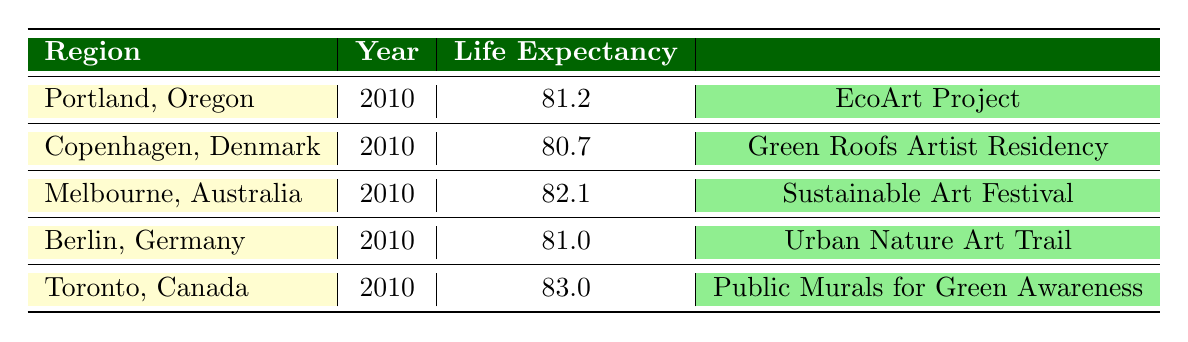What is the average life expectancy listed for Portland, Oregon? The life expectancy for Portland, Oregon, is directly listed in the table as 81.2 years.
Answer: 81.2 Which city has the highest average life expectancy? By comparing the life expectancies across all regions listed, Toronto, Canada, has the highest life expectancy of 83.0 years.
Answer: Toronto, Canada What is the impact rating of the EcoArt Project in Portland? The impact rating for the EcoArt Project is explicitly stated in the table, which is 7.
Answer: 7 Is the life expectancy in Copenhagen, Denmark, higher than that in Berlin, Germany? The table shows that Copenhagen has an average life expectancy of 80.7 years while Berlin has 81.0 years, indicating that Berlin’s life expectancy is higher.
Answer: No What are the average life expectancies for regions with art initiatives rated 8 or higher? The table lists the average life expectancies for Melbourne with an impact rating of 8 (82.1) and Toronto with an impact rating of 8 (83.0). Both need to be averaged: (82.1 + 83.0)/2 = 82.55.
Answer: 82.55 How many regions have an average life expectancy below 82 years? By examining the provided life expectancies: Portland (81.2), Copenhagen (80.7), and Berlin (81.0) are under 82 years, totaling three regions.
Answer: 3 What is the description of the art initiative taking place in Melbourne, Australia? The table states that the initiative, 'Sustainable Art Festival,' emphasizes artists showcasing works that highlight environmental concerns.
Answer: Annual festival where artists showcase works that emphasize environmental concerns Is there a relationship between the impact rating of art initiatives and life expectancy in these regions? A comprehensive review shows Toronto with an initiative rating of 8 and the highest life expectancy of 83.0 years, while Copenhagen, with a lower initiative rating of 9, has lesser life expectancy, suggesting a complex relationship but requires deeper analysis to confirm.
Answer: Requires deeper analysis 